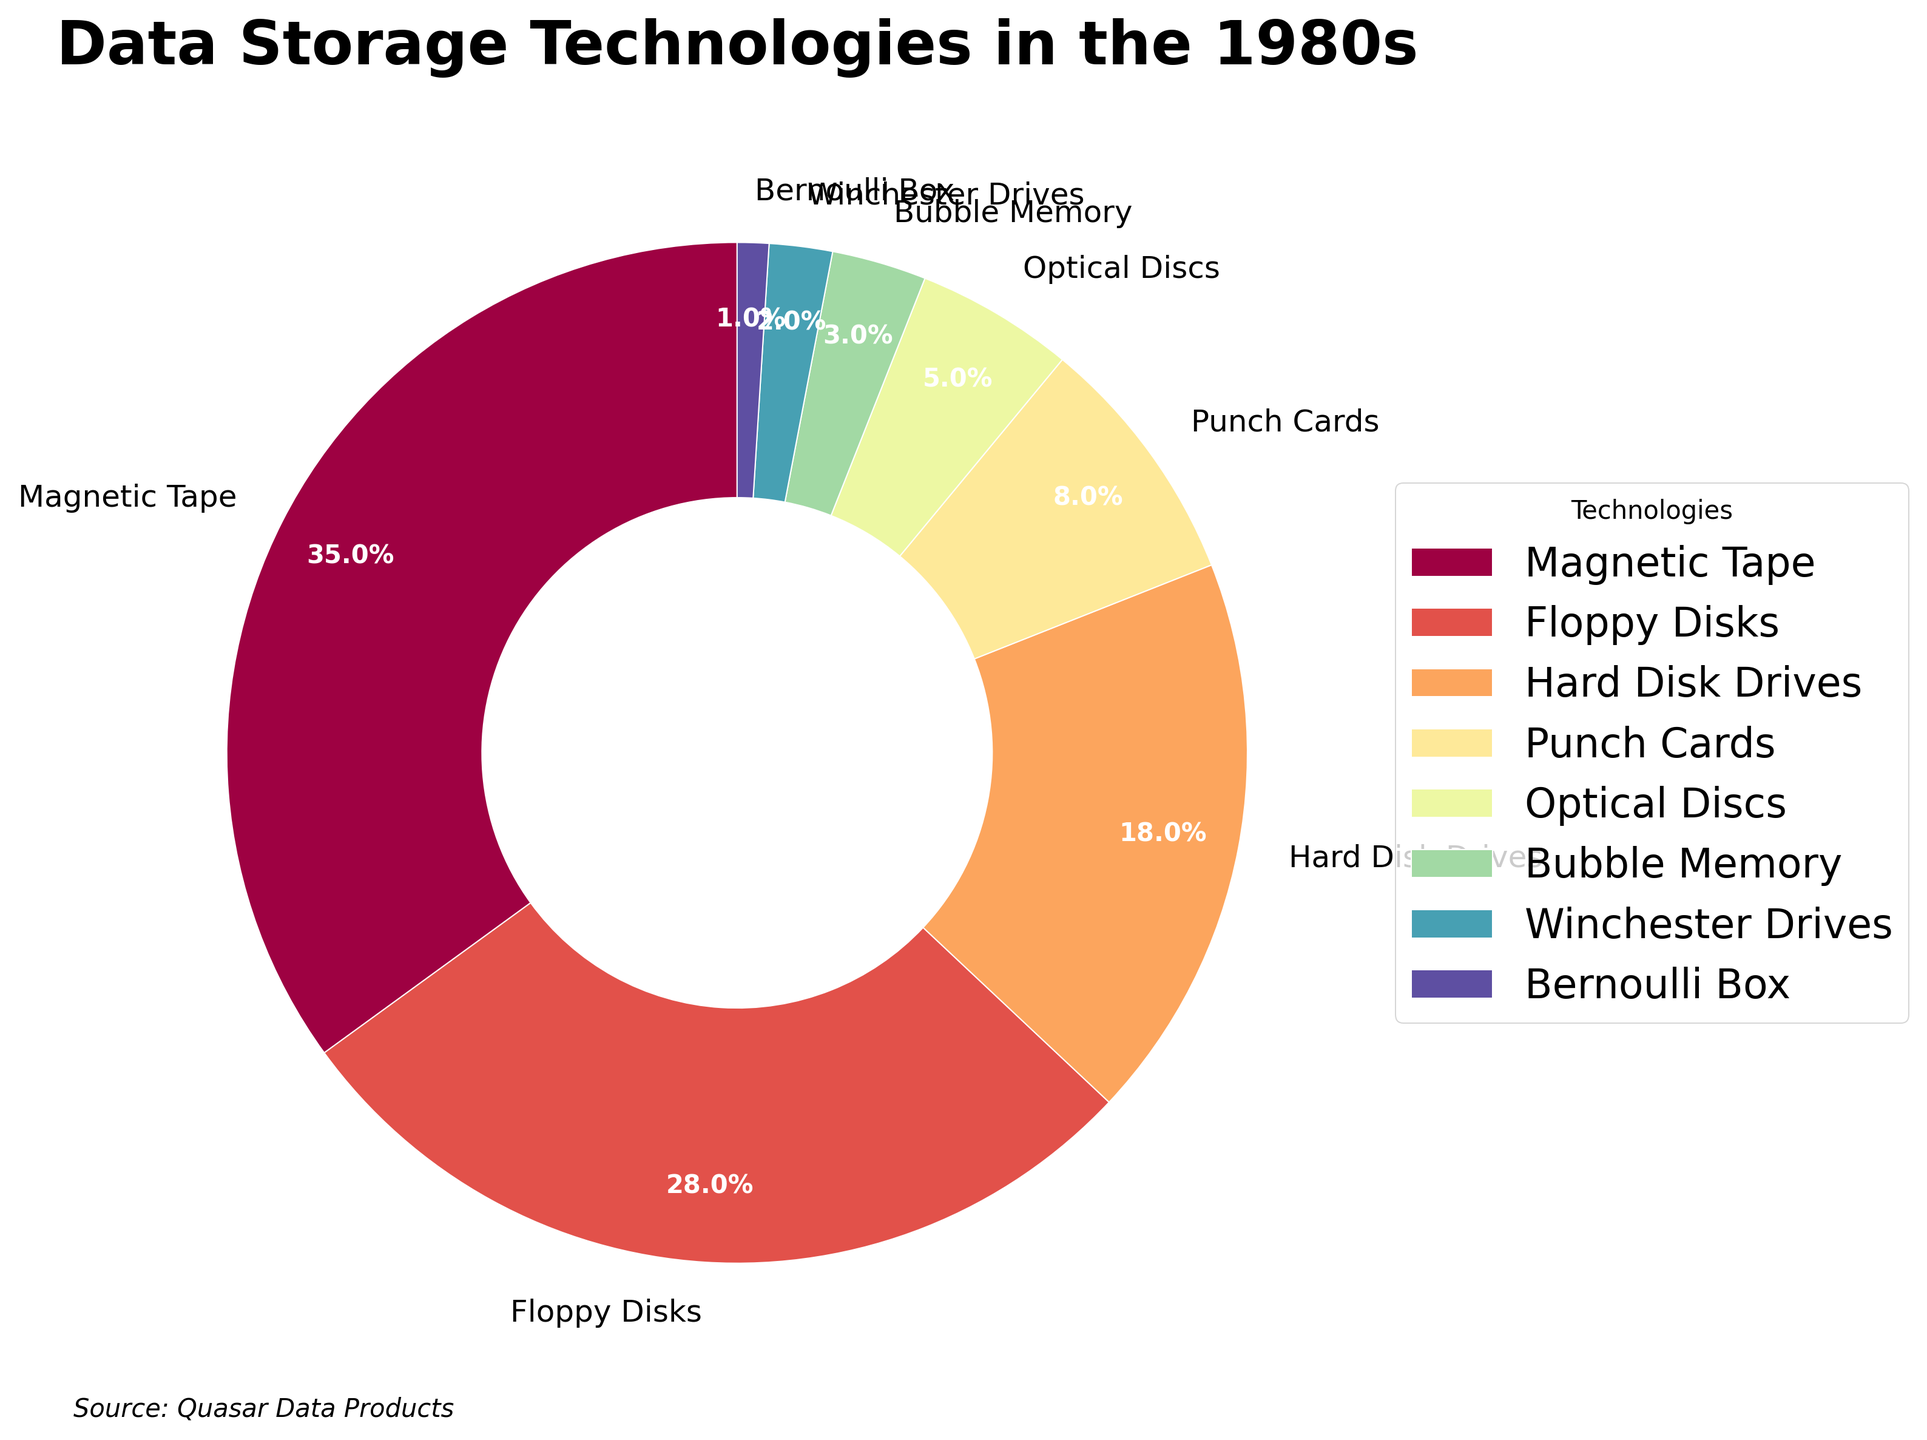What technology has the largest market share? To find the answer, look for the technology with the biggest slice in the pie chart and the highest percentage label.
Answer: Magnetic Tape Which two technologies combined have a market share greater than Hard Disk Drives? First, identify the market share percentage of Hard Disk Drives (18%). Then look for a combination of technologies whose summed market share exceeds 18%. Floppy Disks (28%) alone is greater than 18%.
Answer: Floppy Disks What is the combined market share of Optical Discs and Bubble Memory? Find and add the percentages labeled for Optical Discs (5%) and Bubble Memory (3%). The result is calculated as 5% + 3% = 8%.
Answer: 8% Which data storage technology has the smallest market share? To determine this, identify the smallest slice in the pie chart which corresponds to 1% for the Bernoulli Box.
Answer: Bernoulli Box How much larger is the market share of Magnetic Tape compared to Winchester Drives? Determine the market share for both technologies (Magnetic Tape: 35% and Winchester Drives: 2%). Then compute the difference: 35% - 2% = 33%.
Answer: 33% List all technologies that have less than 10% market share. Identify slices of the pie chart with market shares below 10%: Punch Cards (8%), Optical Discs (5%), Bubble Memory (3%), Winchester Drives (2%), and Bernoulli Box (1%).
Answer: Punch Cards, Optical Discs, Bubble Memory, Winchester Drives, Bernoulli Box What is the total market share for Magnetic Tape, Floppy Disks, and Hard Disk Drives? Add the market shares for the three technologies: Magnetic Tape (35%), Floppy Disks (28%), and Hard Disk Drives (18%). Performing the sum gives 35% + 28% + 18% = 81%.
Answer: 81% What percentage of the total market share is held by technologies other than the top three? First, find the total market share of the top three (Magnetic Tape: 35%, Floppy Disks: 28%, Hard Disk Drives: 18%). Then subtract this from 100%: 100% - (35% + 28% + 18%). That gives 100% - 81% = 19%.
Answer: 19% If Bubble Memory and Winchester Drives combined doubled their market share, what would their new combined percentage be? First, find the current combined share: Bubble Memory (3%) + Winchester Drives (2%) = 5%. Doubling this value results in 5% * 2 = 10%.
Answer: 10% 